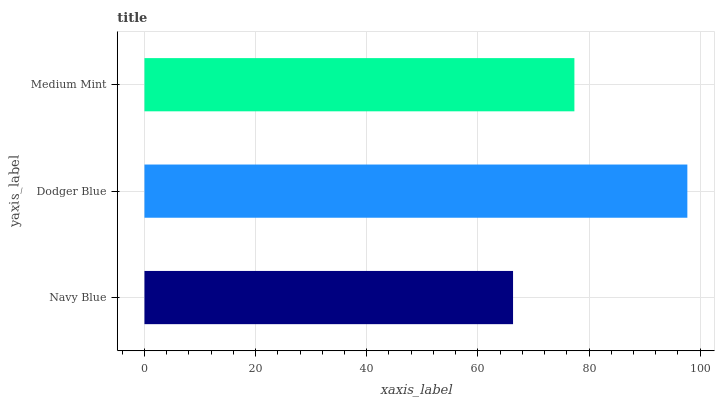Is Navy Blue the minimum?
Answer yes or no. Yes. Is Dodger Blue the maximum?
Answer yes or no. Yes. Is Medium Mint the minimum?
Answer yes or no. No. Is Medium Mint the maximum?
Answer yes or no. No. Is Dodger Blue greater than Medium Mint?
Answer yes or no. Yes. Is Medium Mint less than Dodger Blue?
Answer yes or no. Yes. Is Medium Mint greater than Dodger Blue?
Answer yes or no. No. Is Dodger Blue less than Medium Mint?
Answer yes or no. No. Is Medium Mint the high median?
Answer yes or no. Yes. Is Medium Mint the low median?
Answer yes or no. Yes. Is Navy Blue the high median?
Answer yes or no. No. Is Navy Blue the low median?
Answer yes or no. No. 